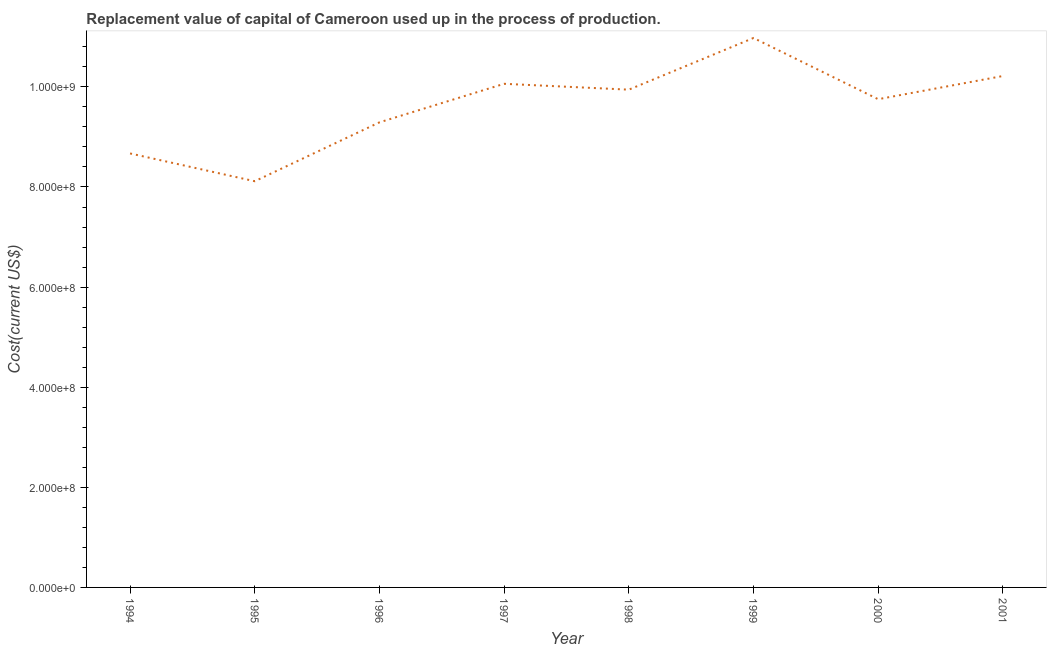What is the consumption of fixed capital in 1997?
Give a very brief answer. 1.01e+09. Across all years, what is the maximum consumption of fixed capital?
Ensure brevity in your answer.  1.10e+09. Across all years, what is the minimum consumption of fixed capital?
Offer a very short reply. 8.11e+08. In which year was the consumption of fixed capital maximum?
Offer a terse response. 1999. What is the sum of the consumption of fixed capital?
Offer a very short reply. 7.70e+09. What is the difference between the consumption of fixed capital in 1994 and 1997?
Your response must be concise. -1.39e+08. What is the average consumption of fixed capital per year?
Your response must be concise. 9.63e+08. What is the median consumption of fixed capital?
Your answer should be compact. 9.85e+08. In how many years, is the consumption of fixed capital greater than 480000000 US$?
Provide a short and direct response. 8. Do a majority of the years between 1998 and 1996 (inclusive) have consumption of fixed capital greater than 560000000 US$?
Your answer should be very brief. No. What is the ratio of the consumption of fixed capital in 1995 to that in 1999?
Your answer should be compact. 0.74. Is the consumption of fixed capital in 1997 less than that in 2000?
Give a very brief answer. No. Is the difference between the consumption of fixed capital in 1995 and 1997 greater than the difference between any two years?
Give a very brief answer. No. What is the difference between the highest and the second highest consumption of fixed capital?
Your answer should be very brief. 7.59e+07. What is the difference between the highest and the lowest consumption of fixed capital?
Provide a short and direct response. 2.86e+08. Does the consumption of fixed capital monotonically increase over the years?
Your answer should be compact. No. How many years are there in the graph?
Provide a short and direct response. 8. Are the values on the major ticks of Y-axis written in scientific E-notation?
Offer a terse response. Yes. Does the graph contain any zero values?
Ensure brevity in your answer.  No. Does the graph contain grids?
Offer a very short reply. No. What is the title of the graph?
Keep it short and to the point. Replacement value of capital of Cameroon used up in the process of production. What is the label or title of the X-axis?
Keep it short and to the point. Year. What is the label or title of the Y-axis?
Keep it short and to the point. Cost(current US$). What is the Cost(current US$) of 1994?
Your answer should be very brief. 8.67e+08. What is the Cost(current US$) in 1995?
Your answer should be very brief. 8.11e+08. What is the Cost(current US$) in 1996?
Make the answer very short. 9.29e+08. What is the Cost(current US$) in 1997?
Make the answer very short. 1.01e+09. What is the Cost(current US$) of 1998?
Give a very brief answer. 9.94e+08. What is the Cost(current US$) of 1999?
Provide a short and direct response. 1.10e+09. What is the Cost(current US$) in 2000?
Offer a very short reply. 9.75e+08. What is the Cost(current US$) of 2001?
Give a very brief answer. 1.02e+09. What is the difference between the Cost(current US$) in 1994 and 1995?
Give a very brief answer. 5.55e+07. What is the difference between the Cost(current US$) in 1994 and 1996?
Keep it short and to the point. -6.21e+07. What is the difference between the Cost(current US$) in 1994 and 1997?
Your answer should be very brief. -1.39e+08. What is the difference between the Cost(current US$) in 1994 and 1998?
Make the answer very short. -1.27e+08. What is the difference between the Cost(current US$) in 1994 and 1999?
Provide a succinct answer. -2.31e+08. What is the difference between the Cost(current US$) in 1994 and 2000?
Your response must be concise. -1.08e+08. What is the difference between the Cost(current US$) in 1994 and 2001?
Provide a short and direct response. -1.55e+08. What is the difference between the Cost(current US$) in 1995 and 1996?
Your answer should be compact. -1.18e+08. What is the difference between the Cost(current US$) in 1995 and 1997?
Your answer should be compact. -1.95e+08. What is the difference between the Cost(current US$) in 1995 and 1998?
Ensure brevity in your answer.  -1.83e+08. What is the difference between the Cost(current US$) in 1995 and 1999?
Provide a short and direct response. -2.86e+08. What is the difference between the Cost(current US$) in 1995 and 2000?
Offer a terse response. -1.64e+08. What is the difference between the Cost(current US$) in 1995 and 2001?
Keep it short and to the point. -2.10e+08. What is the difference between the Cost(current US$) in 1996 and 1997?
Offer a terse response. -7.70e+07. What is the difference between the Cost(current US$) in 1996 and 1998?
Your response must be concise. -6.53e+07. What is the difference between the Cost(current US$) in 1996 and 1999?
Offer a terse response. -1.69e+08. What is the difference between the Cost(current US$) in 1996 and 2000?
Provide a succinct answer. -4.62e+07. What is the difference between the Cost(current US$) in 1996 and 2001?
Your response must be concise. -9.26e+07. What is the difference between the Cost(current US$) in 1997 and 1998?
Offer a very short reply. 1.17e+07. What is the difference between the Cost(current US$) in 1997 and 1999?
Give a very brief answer. -9.15e+07. What is the difference between the Cost(current US$) in 1997 and 2000?
Ensure brevity in your answer.  3.08e+07. What is the difference between the Cost(current US$) in 1997 and 2001?
Offer a very short reply. -1.56e+07. What is the difference between the Cost(current US$) in 1998 and 1999?
Your answer should be compact. -1.03e+08. What is the difference between the Cost(current US$) in 1998 and 2000?
Provide a succinct answer. 1.91e+07. What is the difference between the Cost(current US$) in 1998 and 2001?
Your answer should be very brief. -2.73e+07. What is the difference between the Cost(current US$) in 1999 and 2000?
Keep it short and to the point. 1.22e+08. What is the difference between the Cost(current US$) in 1999 and 2001?
Keep it short and to the point. 7.59e+07. What is the difference between the Cost(current US$) in 2000 and 2001?
Give a very brief answer. -4.63e+07. What is the ratio of the Cost(current US$) in 1994 to that in 1995?
Your answer should be compact. 1.07. What is the ratio of the Cost(current US$) in 1994 to that in 1996?
Provide a short and direct response. 0.93. What is the ratio of the Cost(current US$) in 1994 to that in 1997?
Offer a very short reply. 0.86. What is the ratio of the Cost(current US$) in 1994 to that in 1998?
Keep it short and to the point. 0.87. What is the ratio of the Cost(current US$) in 1994 to that in 1999?
Give a very brief answer. 0.79. What is the ratio of the Cost(current US$) in 1994 to that in 2000?
Ensure brevity in your answer.  0.89. What is the ratio of the Cost(current US$) in 1994 to that in 2001?
Your response must be concise. 0.85. What is the ratio of the Cost(current US$) in 1995 to that in 1996?
Provide a short and direct response. 0.87. What is the ratio of the Cost(current US$) in 1995 to that in 1997?
Offer a terse response. 0.81. What is the ratio of the Cost(current US$) in 1995 to that in 1998?
Keep it short and to the point. 0.82. What is the ratio of the Cost(current US$) in 1995 to that in 1999?
Keep it short and to the point. 0.74. What is the ratio of the Cost(current US$) in 1995 to that in 2000?
Your answer should be very brief. 0.83. What is the ratio of the Cost(current US$) in 1995 to that in 2001?
Provide a succinct answer. 0.79. What is the ratio of the Cost(current US$) in 1996 to that in 1997?
Your answer should be very brief. 0.92. What is the ratio of the Cost(current US$) in 1996 to that in 1998?
Your answer should be very brief. 0.93. What is the ratio of the Cost(current US$) in 1996 to that in 1999?
Your response must be concise. 0.85. What is the ratio of the Cost(current US$) in 1996 to that in 2000?
Give a very brief answer. 0.95. What is the ratio of the Cost(current US$) in 1996 to that in 2001?
Your answer should be compact. 0.91. What is the ratio of the Cost(current US$) in 1997 to that in 1998?
Provide a succinct answer. 1.01. What is the ratio of the Cost(current US$) in 1997 to that in 1999?
Offer a terse response. 0.92. What is the ratio of the Cost(current US$) in 1997 to that in 2000?
Keep it short and to the point. 1.03. What is the ratio of the Cost(current US$) in 1997 to that in 2001?
Your response must be concise. 0.98. What is the ratio of the Cost(current US$) in 1998 to that in 1999?
Provide a short and direct response. 0.91. What is the ratio of the Cost(current US$) in 1998 to that in 2001?
Offer a very short reply. 0.97. What is the ratio of the Cost(current US$) in 1999 to that in 2001?
Provide a short and direct response. 1.07. What is the ratio of the Cost(current US$) in 2000 to that in 2001?
Offer a very short reply. 0.95. 